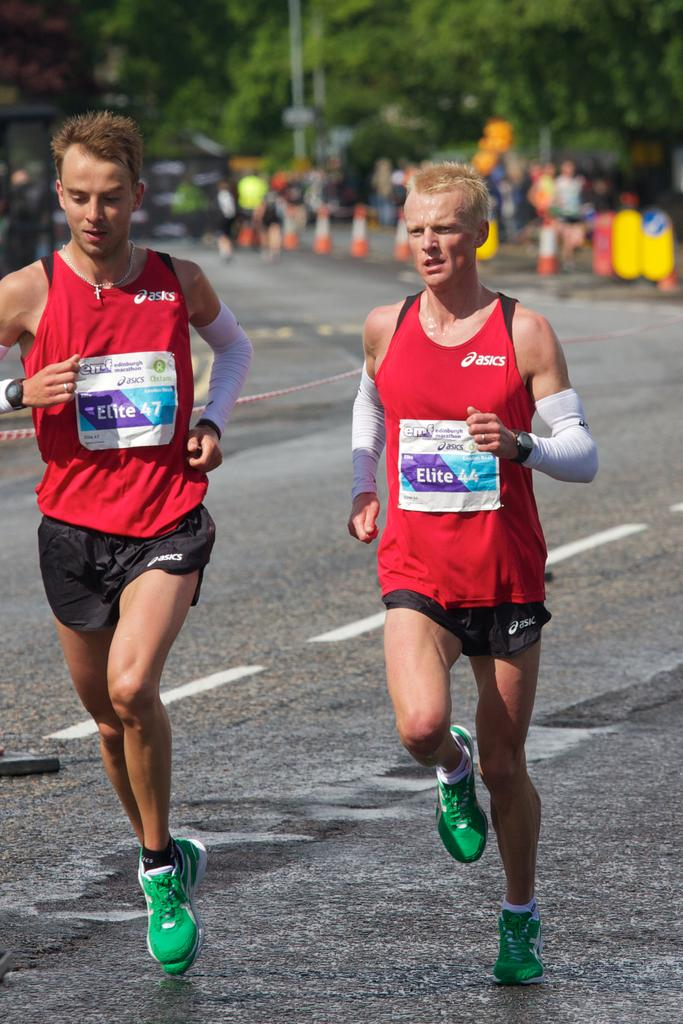<image>
Summarize the visual content of the image. Two men race in the Edinburgh Marathon in asics jerseys.. 